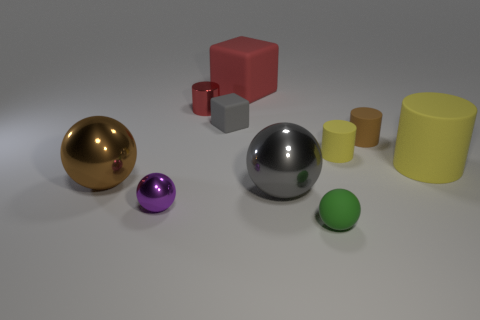There is a big thing that is the same color as the metallic cylinder; what shape is it?
Provide a short and direct response. Cube. There is a big matte cylinder; does it have the same color as the matte cube that is in front of the red metal cylinder?
Your response must be concise. No. Is the number of yellow things in front of the green matte ball greater than the number of big red balls?
Provide a succinct answer. No. What number of objects are either balls to the left of the green rubber thing or red things that are on the left side of the large cube?
Provide a succinct answer. 4. There is a green sphere that is made of the same material as the tiny block; what is its size?
Your answer should be very brief. Small. There is a gray object that is to the right of the red matte cube; is it the same shape as the red matte thing?
Your answer should be compact. No. There is a metal sphere that is the same color as the tiny cube; what is its size?
Make the answer very short. Large. How many green objects are shiny things or things?
Your answer should be very brief. 1. What number of other objects are the same shape as the large red rubber thing?
Provide a succinct answer. 1. The large object that is both in front of the large rubber cube and behind the large brown shiny object has what shape?
Offer a very short reply. Cylinder. 